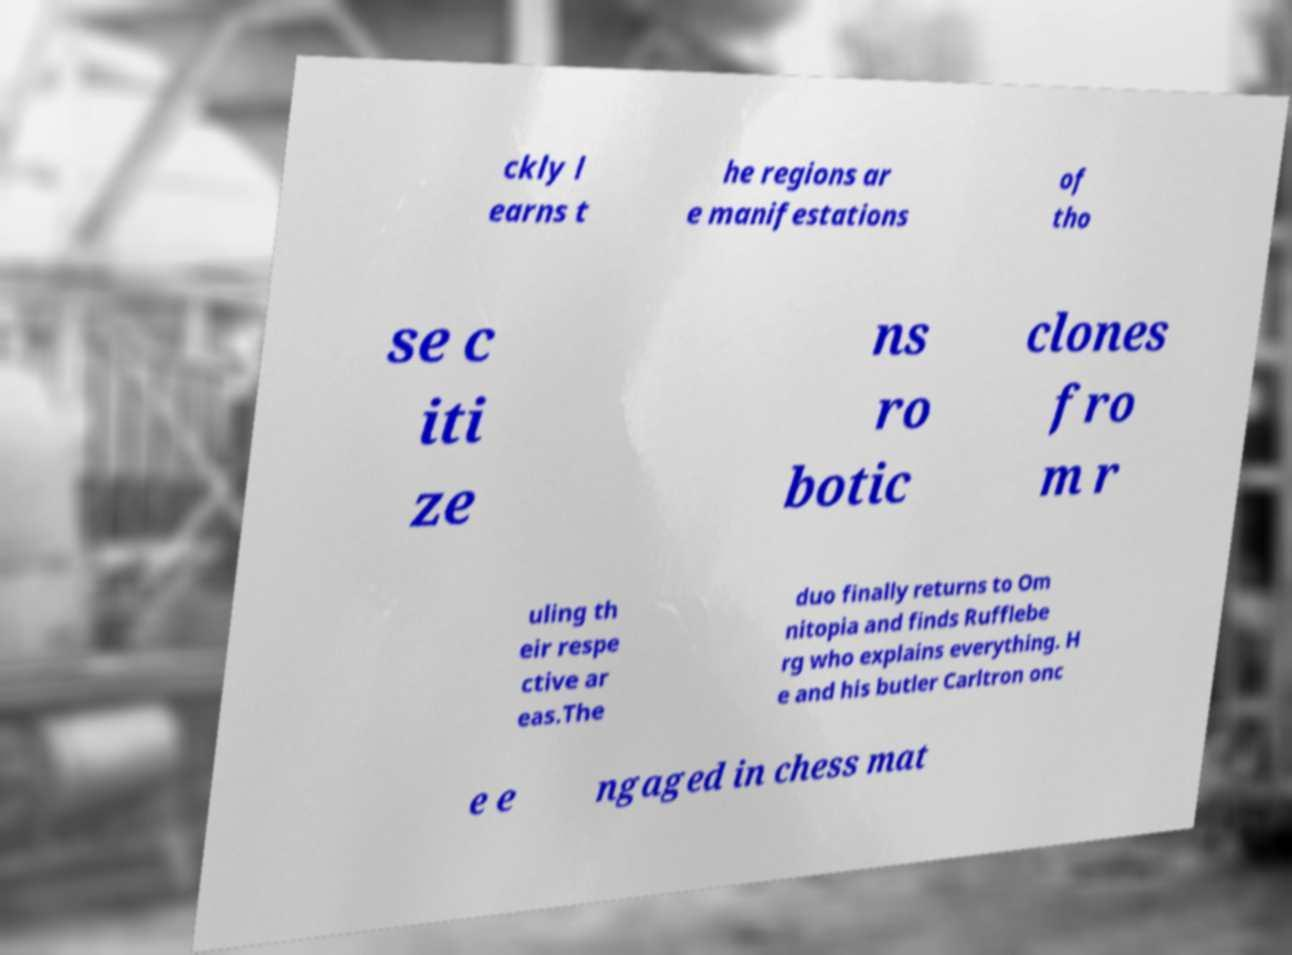Could you assist in decoding the text presented in this image and type it out clearly? ckly l earns t he regions ar e manifestations of tho se c iti ze ns ro botic clones fro m r uling th eir respe ctive ar eas.The duo finally returns to Om nitopia and finds Rufflebe rg who explains everything. H e and his butler Carltron onc e e ngaged in chess mat 